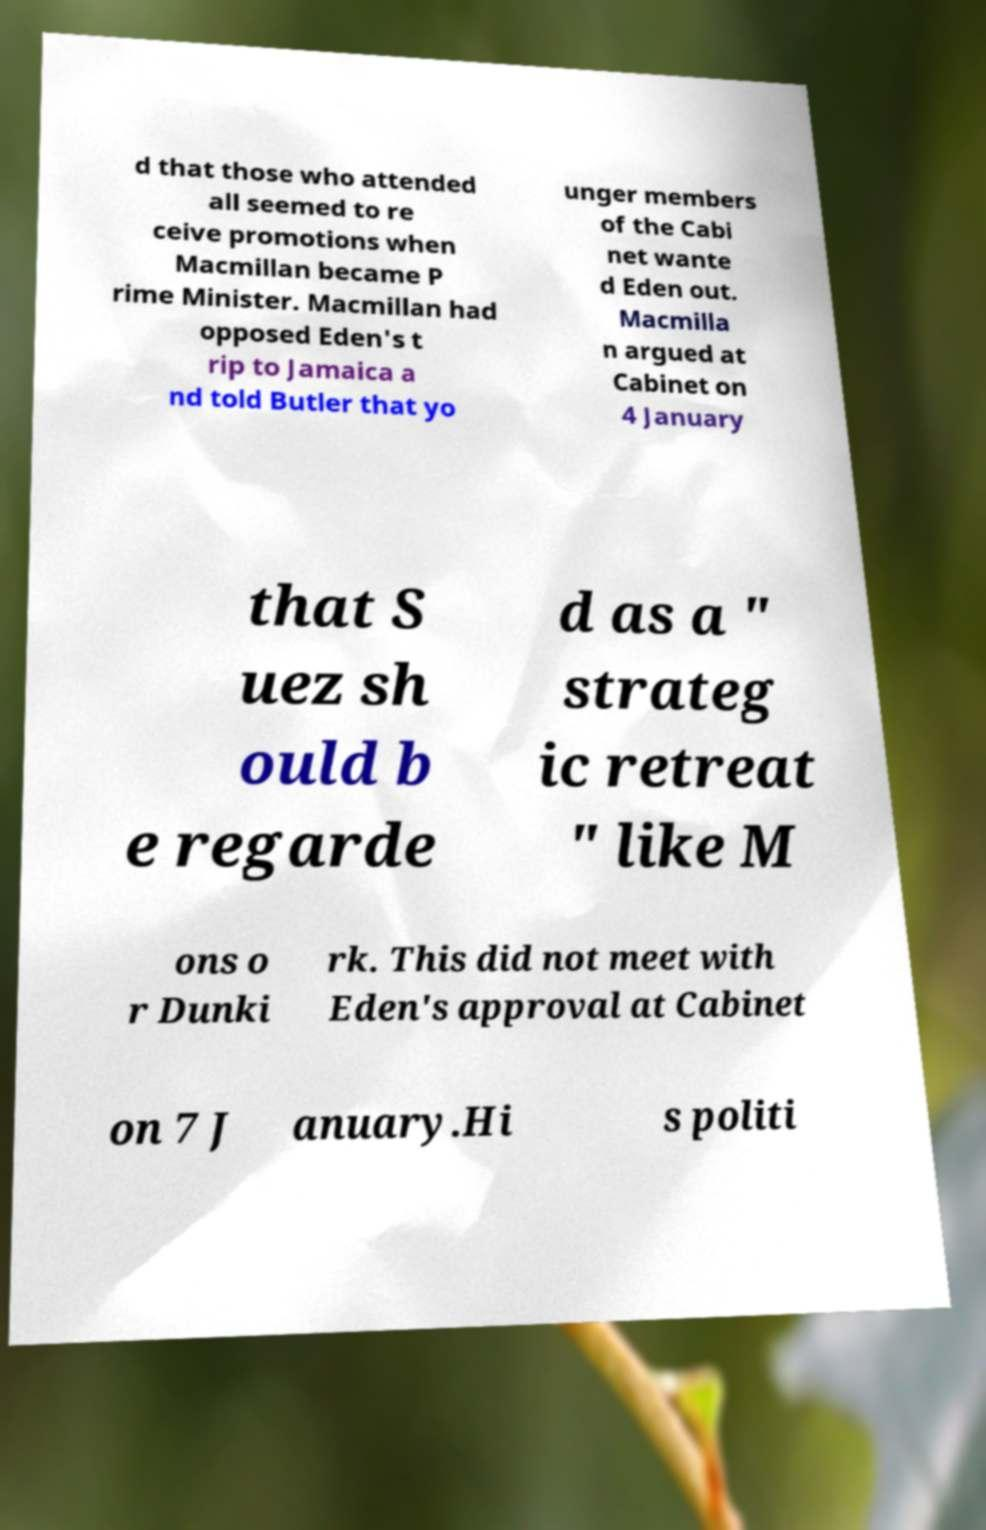Can you read and provide the text displayed in the image?This photo seems to have some interesting text. Can you extract and type it out for me? d that those who attended all seemed to re ceive promotions when Macmillan became P rime Minister. Macmillan had opposed Eden's t rip to Jamaica a nd told Butler that yo unger members of the Cabi net wante d Eden out. Macmilla n argued at Cabinet on 4 January that S uez sh ould b e regarde d as a " strateg ic retreat " like M ons o r Dunki rk. This did not meet with Eden's approval at Cabinet on 7 J anuary.Hi s politi 